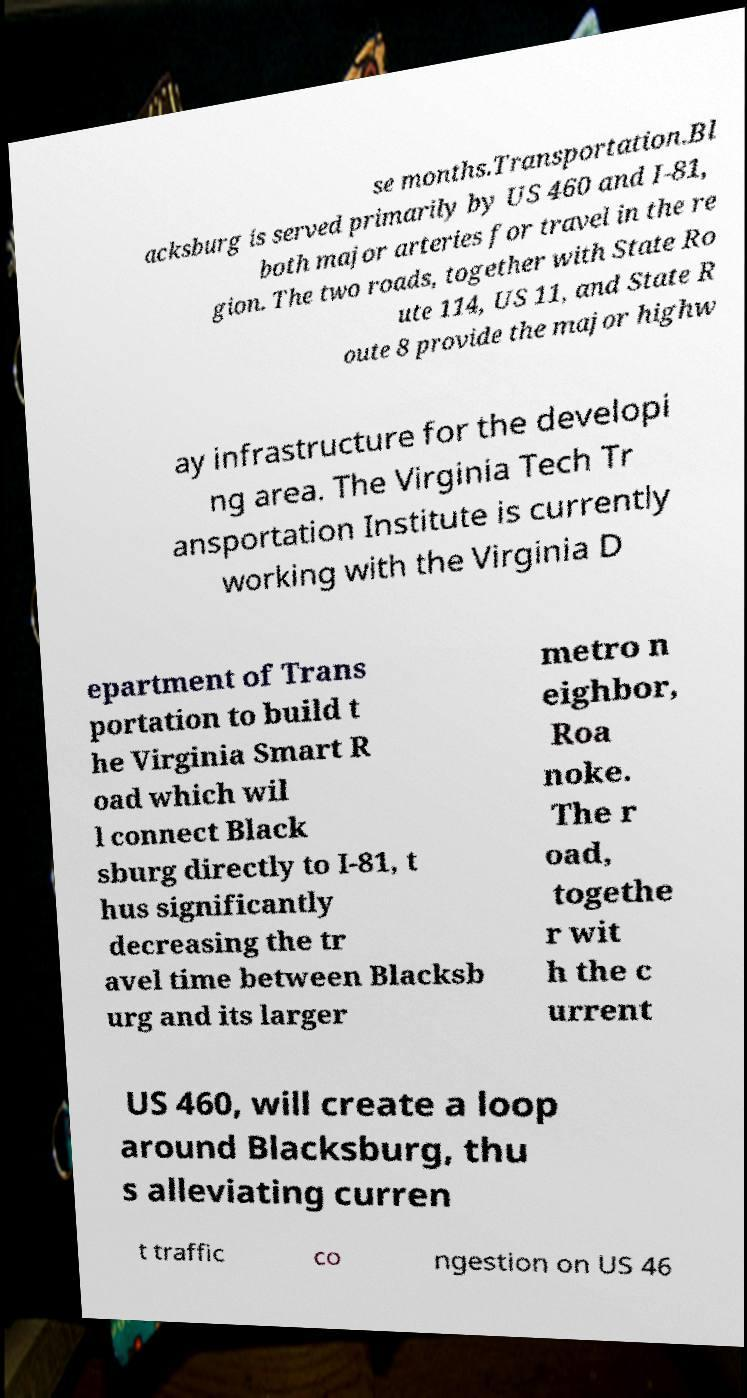For documentation purposes, I need the text within this image transcribed. Could you provide that? se months.Transportation.Bl acksburg is served primarily by US 460 and I-81, both major arteries for travel in the re gion. The two roads, together with State Ro ute 114, US 11, and State R oute 8 provide the major highw ay infrastructure for the developi ng area. The Virginia Tech Tr ansportation Institute is currently working with the Virginia D epartment of Trans portation to build t he Virginia Smart R oad which wil l connect Black sburg directly to I-81, t hus significantly decreasing the tr avel time between Blacksb urg and its larger metro n eighbor, Roa noke. The r oad, togethe r wit h the c urrent US 460, will create a loop around Blacksburg, thu s alleviating curren t traffic co ngestion on US 46 